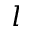Convert formula to latex. <formula><loc_0><loc_0><loc_500><loc_500>l</formula> 